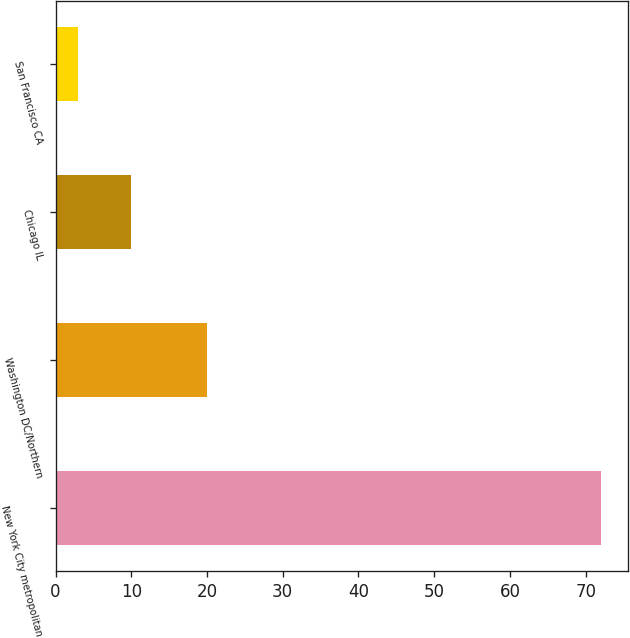<chart> <loc_0><loc_0><loc_500><loc_500><bar_chart><fcel>New York City metropolitan<fcel>Washington DC/Northern<fcel>Chicago IL<fcel>San Francisco CA<nl><fcel>72<fcel>20<fcel>9.9<fcel>3<nl></chart> 